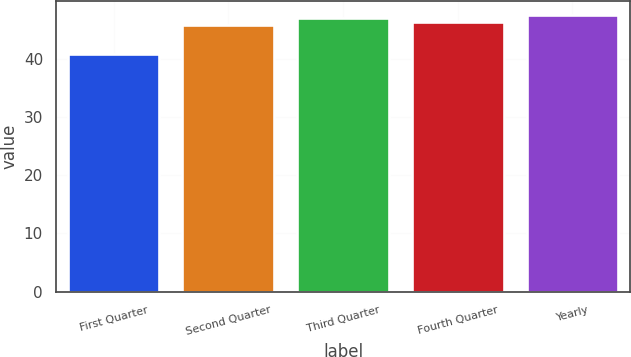Convert chart. <chart><loc_0><loc_0><loc_500><loc_500><bar_chart><fcel>First Quarter<fcel>Second Quarter<fcel>Third Quarter<fcel>Fourth Quarter<fcel>Yearly<nl><fcel>40.8<fcel>45.8<fcel>46.94<fcel>46.37<fcel>47.51<nl></chart> 